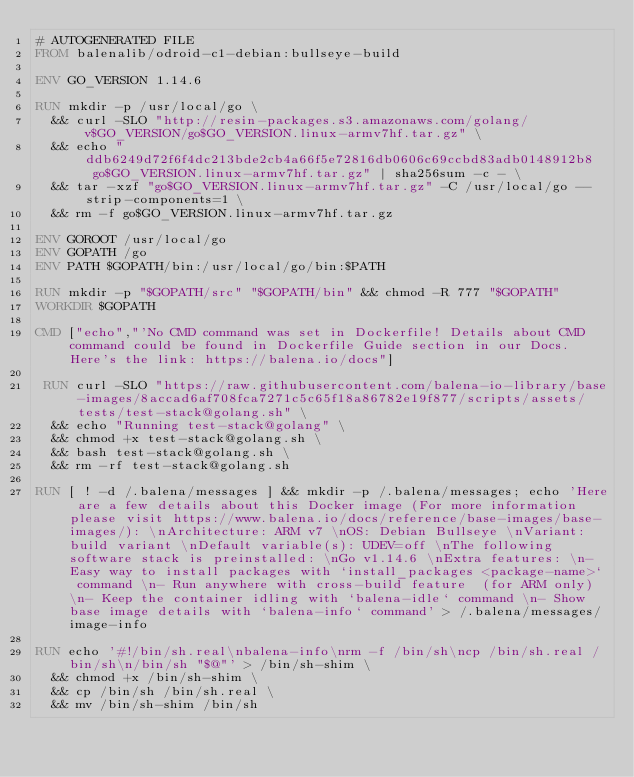<code> <loc_0><loc_0><loc_500><loc_500><_Dockerfile_># AUTOGENERATED FILE
FROM balenalib/odroid-c1-debian:bullseye-build

ENV GO_VERSION 1.14.6

RUN mkdir -p /usr/local/go \
	&& curl -SLO "http://resin-packages.s3.amazonaws.com/golang/v$GO_VERSION/go$GO_VERSION.linux-armv7hf.tar.gz" \
	&& echo "ddb6249d72f6f4dc213bde2cb4a66f5e72816db0606c69ccbd83adb0148912b8  go$GO_VERSION.linux-armv7hf.tar.gz" | sha256sum -c - \
	&& tar -xzf "go$GO_VERSION.linux-armv7hf.tar.gz" -C /usr/local/go --strip-components=1 \
	&& rm -f go$GO_VERSION.linux-armv7hf.tar.gz

ENV GOROOT /usr/local/go
ENV GOPATH /go
ENV PATH $GOPATH/bin:/usr/local/go/bin:$PATH

RUN mkdir -p "$GOPATH/src" "$GOPATH/bin" && chmod -R 777 "$GOPATH"
WORKDIR $GOPATH

CMD ["echo","'No CMD command was set in Dockerfile! Details about CMD command could be found in Dockerfile Guide section in our Docs. Here's the link: https://balena.io/docs"]

 RUN curl -SLO "https://raw.githubusercontent.com/balena-io-library/base-images/8accad6af708fca7271c5c65f18a86782e19f877/scripts/assets/tests/test-stack@golang.sh" \
  && echo "Running test-stack@golang" \
  && chmod +x test-stack@golang.sh \
  && bash test-stack@golang.sh \
  && rm -rf test-stack@golang.sh 

RUN [ ! -d /.balena/messages ] && mkdir -p /.balena/messages; echo 'Here are a few details about this Docker image (For more information please visit https://www.balena.io/docs/reference/base-images/base-images/): \nArchitecture: ARM v7 \nOS: Debian Bullseye \nVariant: build variant \nDefault variable(s): UDEV=off \nThe following software stack is preinstalled: \nGo v1.14.6 \nExtra features: \n- Easy way to install packages with `install_packages <package-name>` command \n- Run anywhere with cross-build feature  (for ARM only) \n- Keep the container idling with `balena-idle` command \n- Show base image details with `balena-info` command' > /.balena/messages/image-info

RUN echo '#!/bin/sh.real\nbalena-info\nrm -f /bin/sh\ncp /bin/sh.real /bin/sh\n/bin/sh "$@"' > /bin/sh-shim \
	&& chmod +x /bin/sh-shim \
	&& cp /bin/sh /bin/sh.real \
	&& mv /bin/sh-shim /bin/sh</code> 